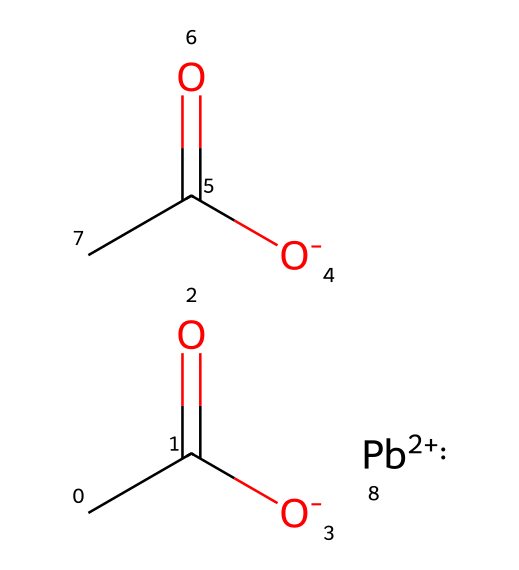What is the overall charge of lead acetate? The lead ion in the structure is represented as Pb+2, indicating it has a charge of +2. Since the acetate ions (O- and OC(=O)C) are both negatively charged, the overall charge can be concluded from these charges. In total, it has a net charge of 0 when combined with the lead ion.
Answer: zero How many acetate groups are present in the chemical structure? From the SMILES representation, we can see two acetate (-C(=O)O) groups. Each acetate ion has the format represented in the formula, confirming there are two.
Answer: two What type of compound is lead acetate classified as? The presence of lead and acetate ions indicates that this compound is classified as a lead salt. Salts are formed from the neutralization reaction of an acid and a base, and since acetate is the conjugate base of acetic acid, lead acetate can be classified as a salt.
Answer: salt Which elements are present in the lead acetate compound? By analyzing the SMILES string, we can identify the presence of carbon (C), oxygen (O), and lead (Pb). Each individual component can be identified in the structure, confirming these three elements.
Answer: carbon, oxygen, lead What is the number of oxygen atoms in lead acetate? In the structure, each acetate group contains two oxygen atoms and since there are two acetate groups, this results in a total of four oxygen atoms. Moreover, there is one additional oxygen in the format of O- from acetate making a total of five.
Answer: five What indicates the toxicity of lead acetate in its structure? The presence of the lead ion (Pb+2) indicates potential toxicity, as lead is a heavy metal known for its harmful effects on human health. This property is a defining characteristic of the compound, highlighting its toxic nature.
Answer: lead ion 